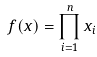<formula> <loc_0><loc_0><loc_500><loc_500>f ( x ) = \prod _ { i = 1 } ^ { n } x _ { i }</formula> 